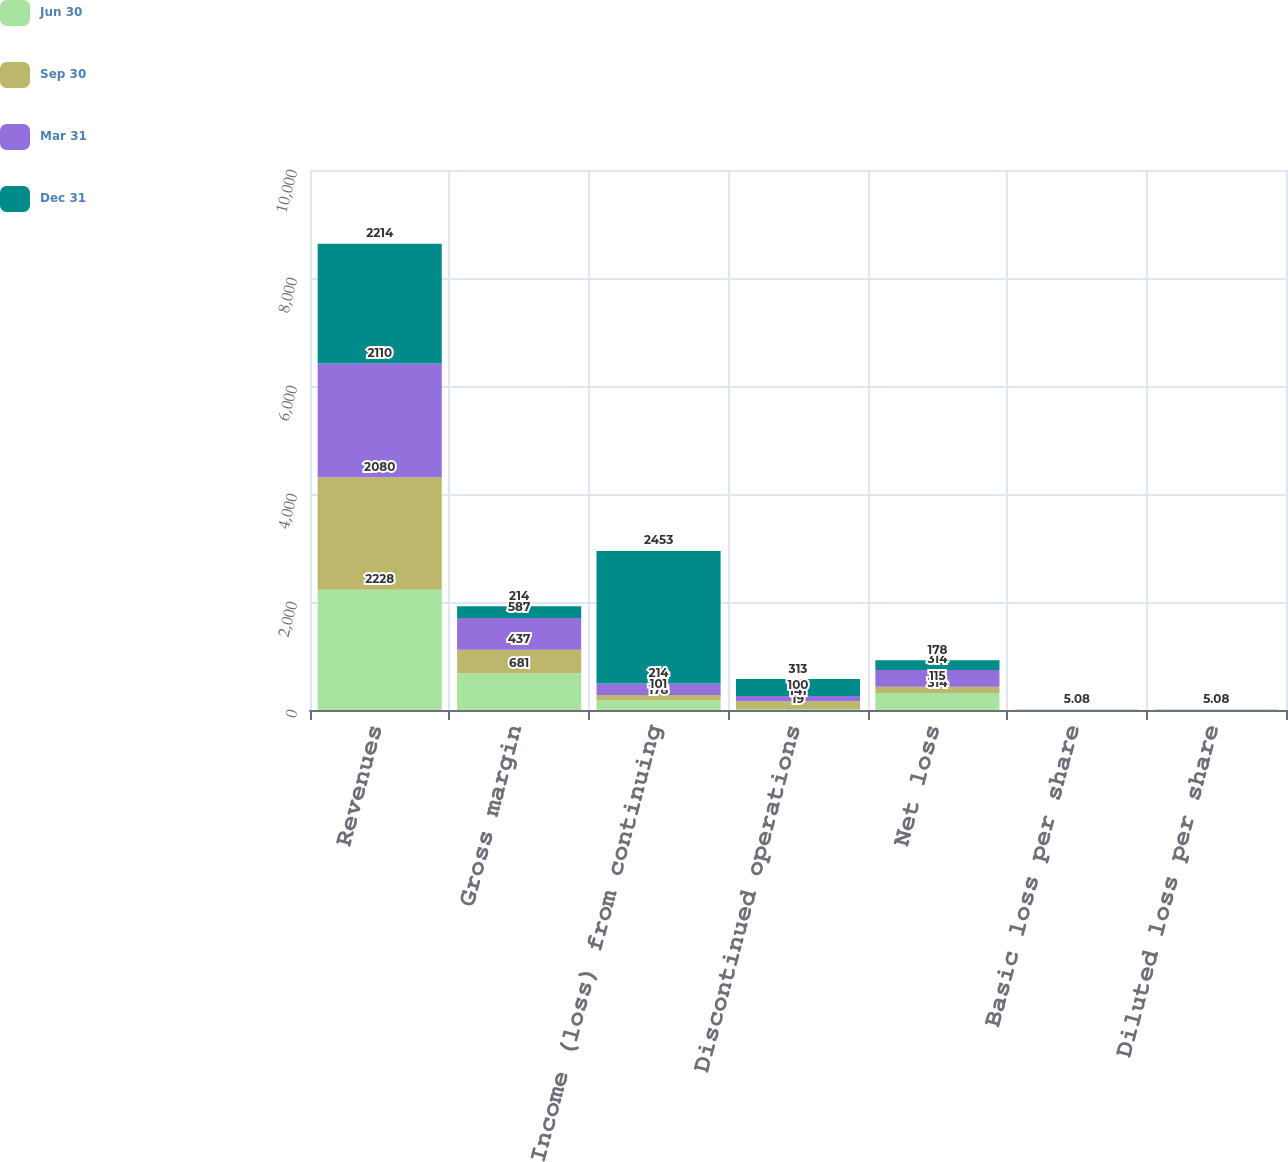Convert chart. <chart><loc_0><loc_0><loc_500><loc_500><stacked_bar_chart><ecel><fcel>Revenues<fcel>Gross margin<fcel>Income (loss) from continuing<fcel>Discontinued operations<fcel>Net loss<fcel>Basic loss per share<fcel>Diluted loss per share<nl><fcel>Jun 30<fcel>2228<fcel>681<fcel>178<fcel>19<fcel>314<fcel>0.58<fcel>0.58<nl><fcel>Sep 30<fcel>2080<fcel>437<fcel>101<fcel>141<fcel>115<fcel>0.22<fcel>0.22<nl><fcel>Mar 31<fcel>2110<fcel>587<fcel>214<fcel>100<fcel>314<fcel>0.58<fcel>0.58<nl><fcel>Dec 31<fcel>2214<fcel>214<fcel>2453<fcel>313<fcel>178<fcel>5.08<fcel>5.08<nl></chart> 